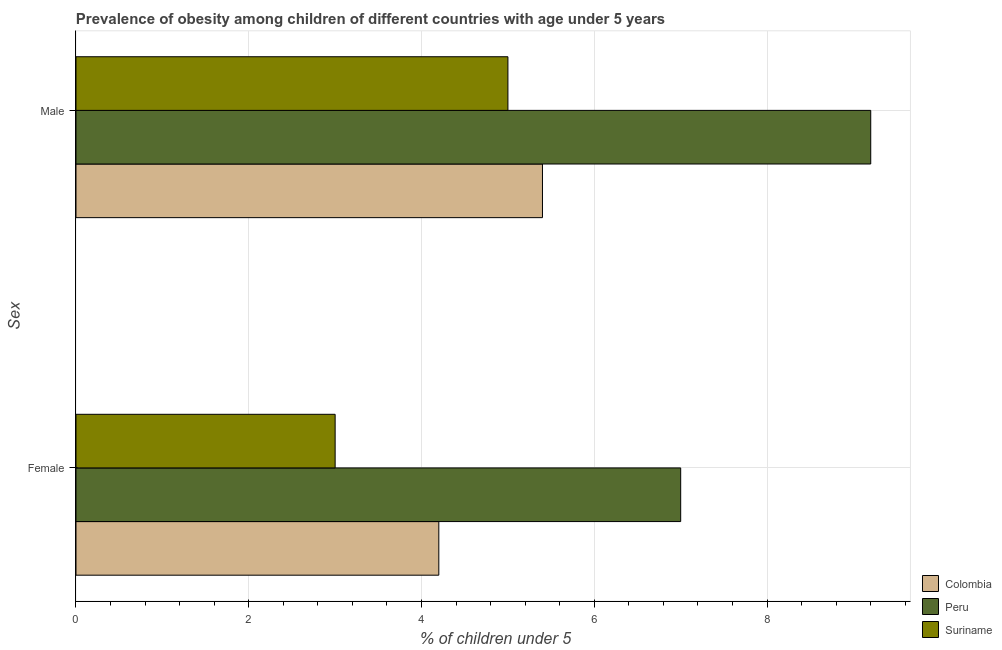How many different coloured bars are there?
Ensure brevity in your answer.  3. Are the number of bars on each tick of the Y-axis equal?
Offer a very short reply. Yes. How many bars are there on the 1st tick from the top?
Your answer should be very brief. 3. Across all countries, what is the maximum percentage of obese female children?
Ensure brevity in your answer.  7. Across all countries, what is the minimum percentage of obese female children?
Your answer should be compact. 3. In which country was the percentage of obese female children minimum?
Your answer should be very brief. Suriname. What is the total percentage of obese male children in the graph?
Make the answer very short. 19.6. What is the difference between the percentage of obese female children in Suriname and the percentage of obese male children in Colombia?
Ensure brevity in your answer.  -2.4. What is the average percentage of obese female children per country?
Your answer should be very brief. 4.73. What is the difference between the percentage of obese male children and percentage of obese female children in Colombia?
Provide a succinct answer. 1.2. In how many countries, is the percentage of obese female children greater than 2 %?
Provide a succinct answer. 3. What is the ratio of the percentage of obese male children in Peru to that in Colombia?
Your answer should be compact. 1.7. What does the 3rd bar from the bottom in Female represents?
Your answer should be compact. Suriname. How many bars are there?
Your answer should be compact. 6. Are all the bars in the graph horizontal?
Make the answer very short. Yes. What is the difference between two consecutive major ticks on the X-axis?
Give a very brief answer. 2. Are the values on the major ticks of X-axis written in scientific E-notation?
Your answer should be very brief. No. Does the graph contain grids?
Ensure brevity in your answer.  Yes. How many legend labels are there?
Offer a terse response. 3. How are the legend labels stacked?
Your response must be concise. Vertical. What is the title of the graph?
Your response must be concise. Prevalence of obesity among children of different countries with age under 5 years. Does "St. Martin (French part)" appear as one of the legend labels in the graph?
Provide a short and direct response. No. What is the label or title of the X-axis?
Ensure brevity in your answer.   % of children under 5. What is the label or title of the Y-axis?
Keep it short and to the point. Sex. What is the  % of children under 5 in Colombia in Female?
Provide a succinct answer. 4.2. What is the  % of children under 5 in Peru in Female?
Provide a short and direct response. 7. What is the  % of children under 5 of Suriname in Female?
Provide a short and direct response. 3. What is the  % of children under 5 in Colombia in Male?
Give a very brief answer. 5.4. What is the  % of children under 5 of Peru in Male?
Provide a succinct answer. 9.2. What is the  % of children under 5 in Suriname in Male?
Offer a very short reply. 5. Across all Sex, what is the maximum  % of children under 5 of Colombia?
Make the answer very short. 5.4. Across all Sex, what is the maximum  % of children under 5 of Peru?
Your answer should be very brief. 9.2. Across all Sex, what is the maximum  % of children under 5 in Suriname?
Ensure brevity in your answer.  5. Across all Sex, what is the minimum  % of children under 5 of Colombia?
Keep it short and to the point. 4.2. What is the total  % of children under 5 in Colombia in the graph?
Ensure brevity in your answer.  9.6. What is the total  % of children under 5 of Suriname in the graph?
Provide a succinct answer. 8. What is the difference between the  % of children under 5 in Colombia in Female and the  % of children under 5 in Suriname in Male?
Your answer should be very brief. -0.8. What is the difference between the  % of children under 5 in Peru in Female and the  % of children under 5 in Suriname in Male?
Offer a terse response. 2. What is the average  % of children under 5 of Colombia per Sex?
Your answer should be compact. 4.8. What is the average  % of children under 5 of Peru per Sex?
Provide a succinct answer. 8.1. What is the difference between the  % of children under 5 in Colombia and  % of children under 5 in Suriname in Female?
Offer a very short reply. 1.2. What is the difference between the  % of children under 5 of Colombia and  % of children under 5 of Peru in Male?
Your response must be concise. -3.8. What is the ratio of the  % of children under 5 of Peru in Female to that in Male?
Ensure brevity in your answer.  0.76. What is the ratio of the  % of children under 5 in Suriname in Female to that in Male?
Offer a very short reply. 0.6. What is the difference between the highest and the lowest  % of children under 5 of Colombia?
Your response must be concise. 1.2. What is the difference between the highest and the lowest  % of children under 5 of Peru?
Offer a terse response. 2.2. 